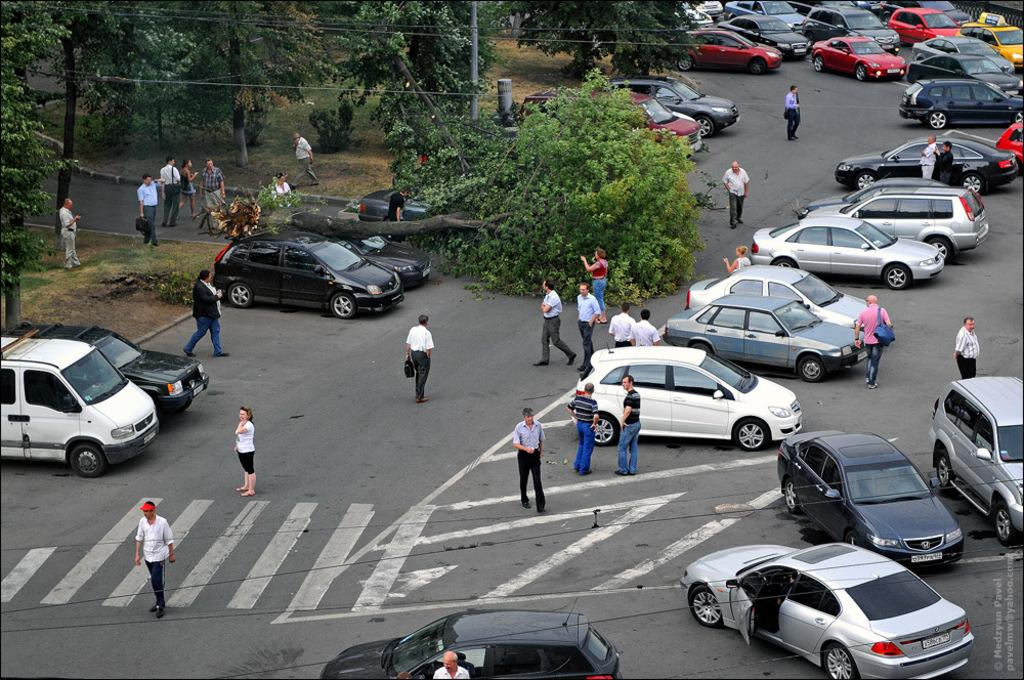What is happening on the road in the image? There are many cars on the road in the image. What else can be seen in the image besides cars? There are many people walking in the image. What type of vegetation is on the left side of the image? There are trees on the left side of the image. Where is the cup placed in the image? There is no cup present in the image. What type of border can be seen surrounding the image? The image does not show a border; it is a photograph or illustration with edges that are not part of the scene. 